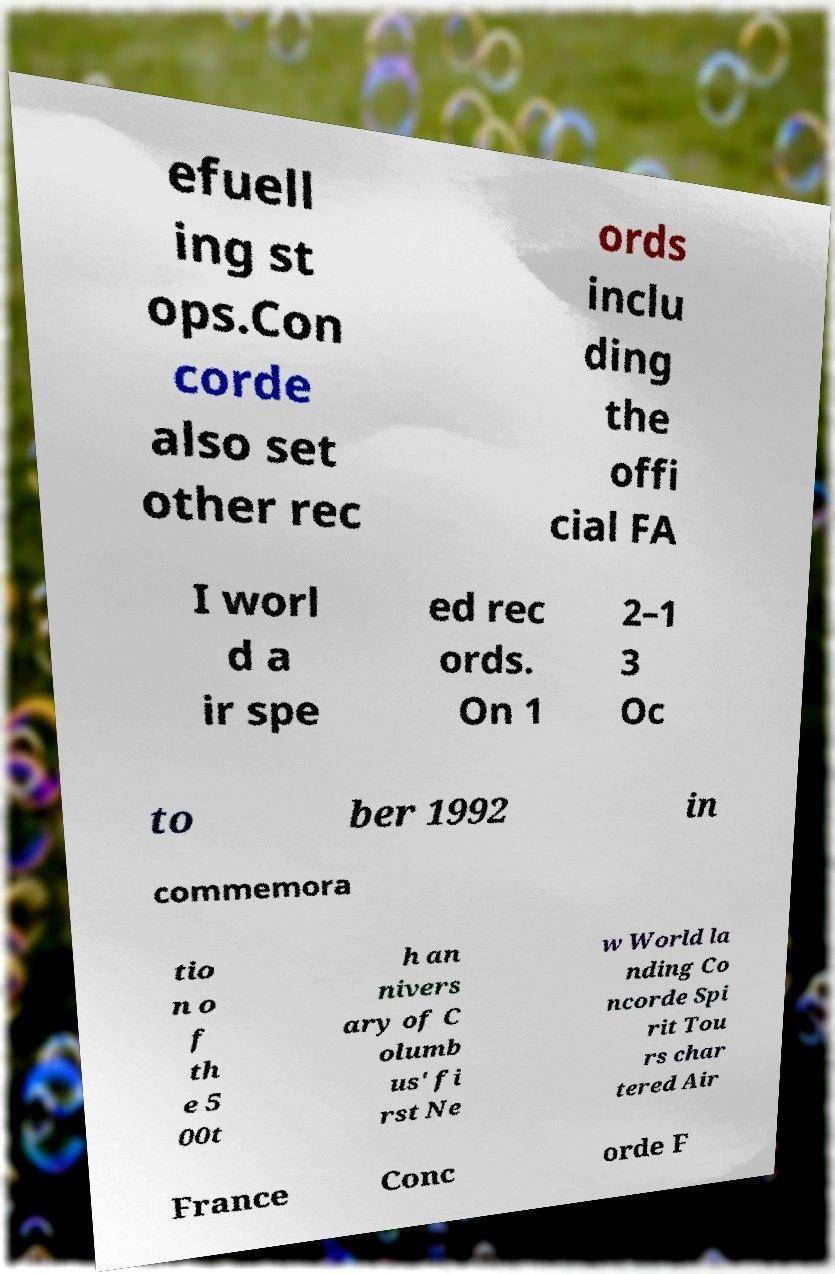Can you read and provide the text displayed in the image?This photo seems to have some interesting text. Can you extract and type it out for me? efuell ing st ops.Con corde also set other rec ords inclu ding the offi cial FA I worl d a ir spe ed rec ords. On 1 2–1 3 Oc to ber 1992 in commemora tio n o f th e 5 00t h an nivers ary of C olumb us' fi rst Ne w World la nding Co ncorde Spi rit Tou rs char tered Air France Conc orde F 